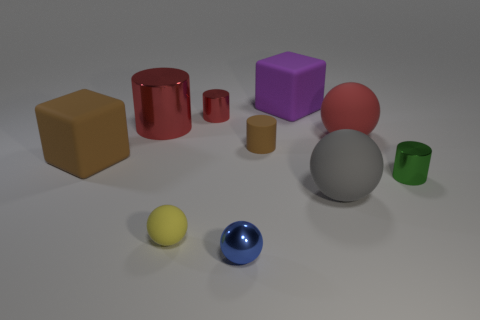The tiny object that is the same color as the big metallic object is what shape?
Your answer should be very brief. Cylinder. What is the size of the brown rubber thing that is the same shape as the green metal object?
Give a very brief answer. Small. What material is the big ball that is right of the large ball that is to the left of the big red rubber sphere?
Your answer should be very brief. Rubber. Is the gray matte thing the same shape as the green thing?
Your answer should be very brief. No. How many large matte objects are to the left of the large red matte object and behind the rubber cylinder?
Your answer should be compact. 1. Are there the same number of metal objects in front of the tiny brown rubber thing and large things in front of the small blue metallic sphere?
Your response must be concise. No. Does the ball that is behind the big gray sphere have the same size as the red metallic thing left of the small red cylinder?
Your answer should be very brief. Yes. There is a object that is both in front of the tiny brown cylinder and to the right of the large gray thing; what material is it?
Offer a very short reply. Metal. Is the number of big green matte spheres less than the number of big brown matte objects?
Offer a very short reply. Yes. There is a matte sphere behind the cylinder that is right of the gray rubber thing; how big is it?
Give a very brief answer. Large. 